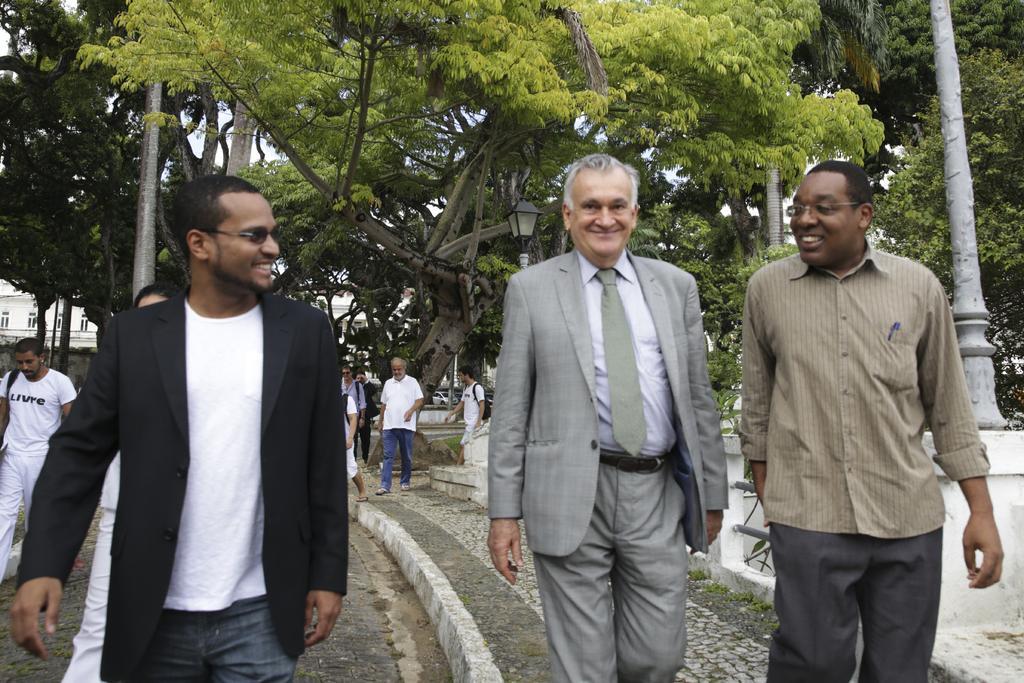Please provide a concise description of this image. In this image we can see these people walking and smiling. In the background, we can see a few more people walking, trees, poles, building and the sky. 